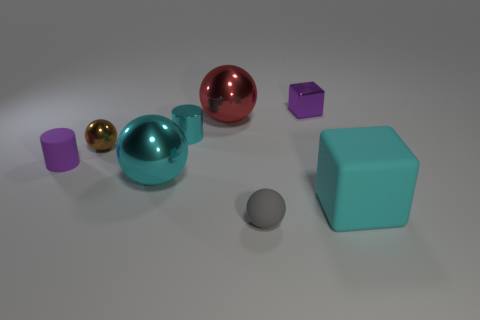Subtract 2 spheres. How many spheres are left? 2 Subtract all metallic balls. How many balls are left? 1 Add 1 large cyan matte things. How many objects exist? 9 Subtract all yellow balls. Subtract all gray cylinders. How many balls are left? 4 Subtract 0 blue cubes. How many objects are left? 8 Subtract all purple things. Subtract all tiny red rubber cubes. How many objects are left? 6 Add 1 large red balls. How many large red balls are left? 2 Add 6 spheres. How many spheres exist? 10 